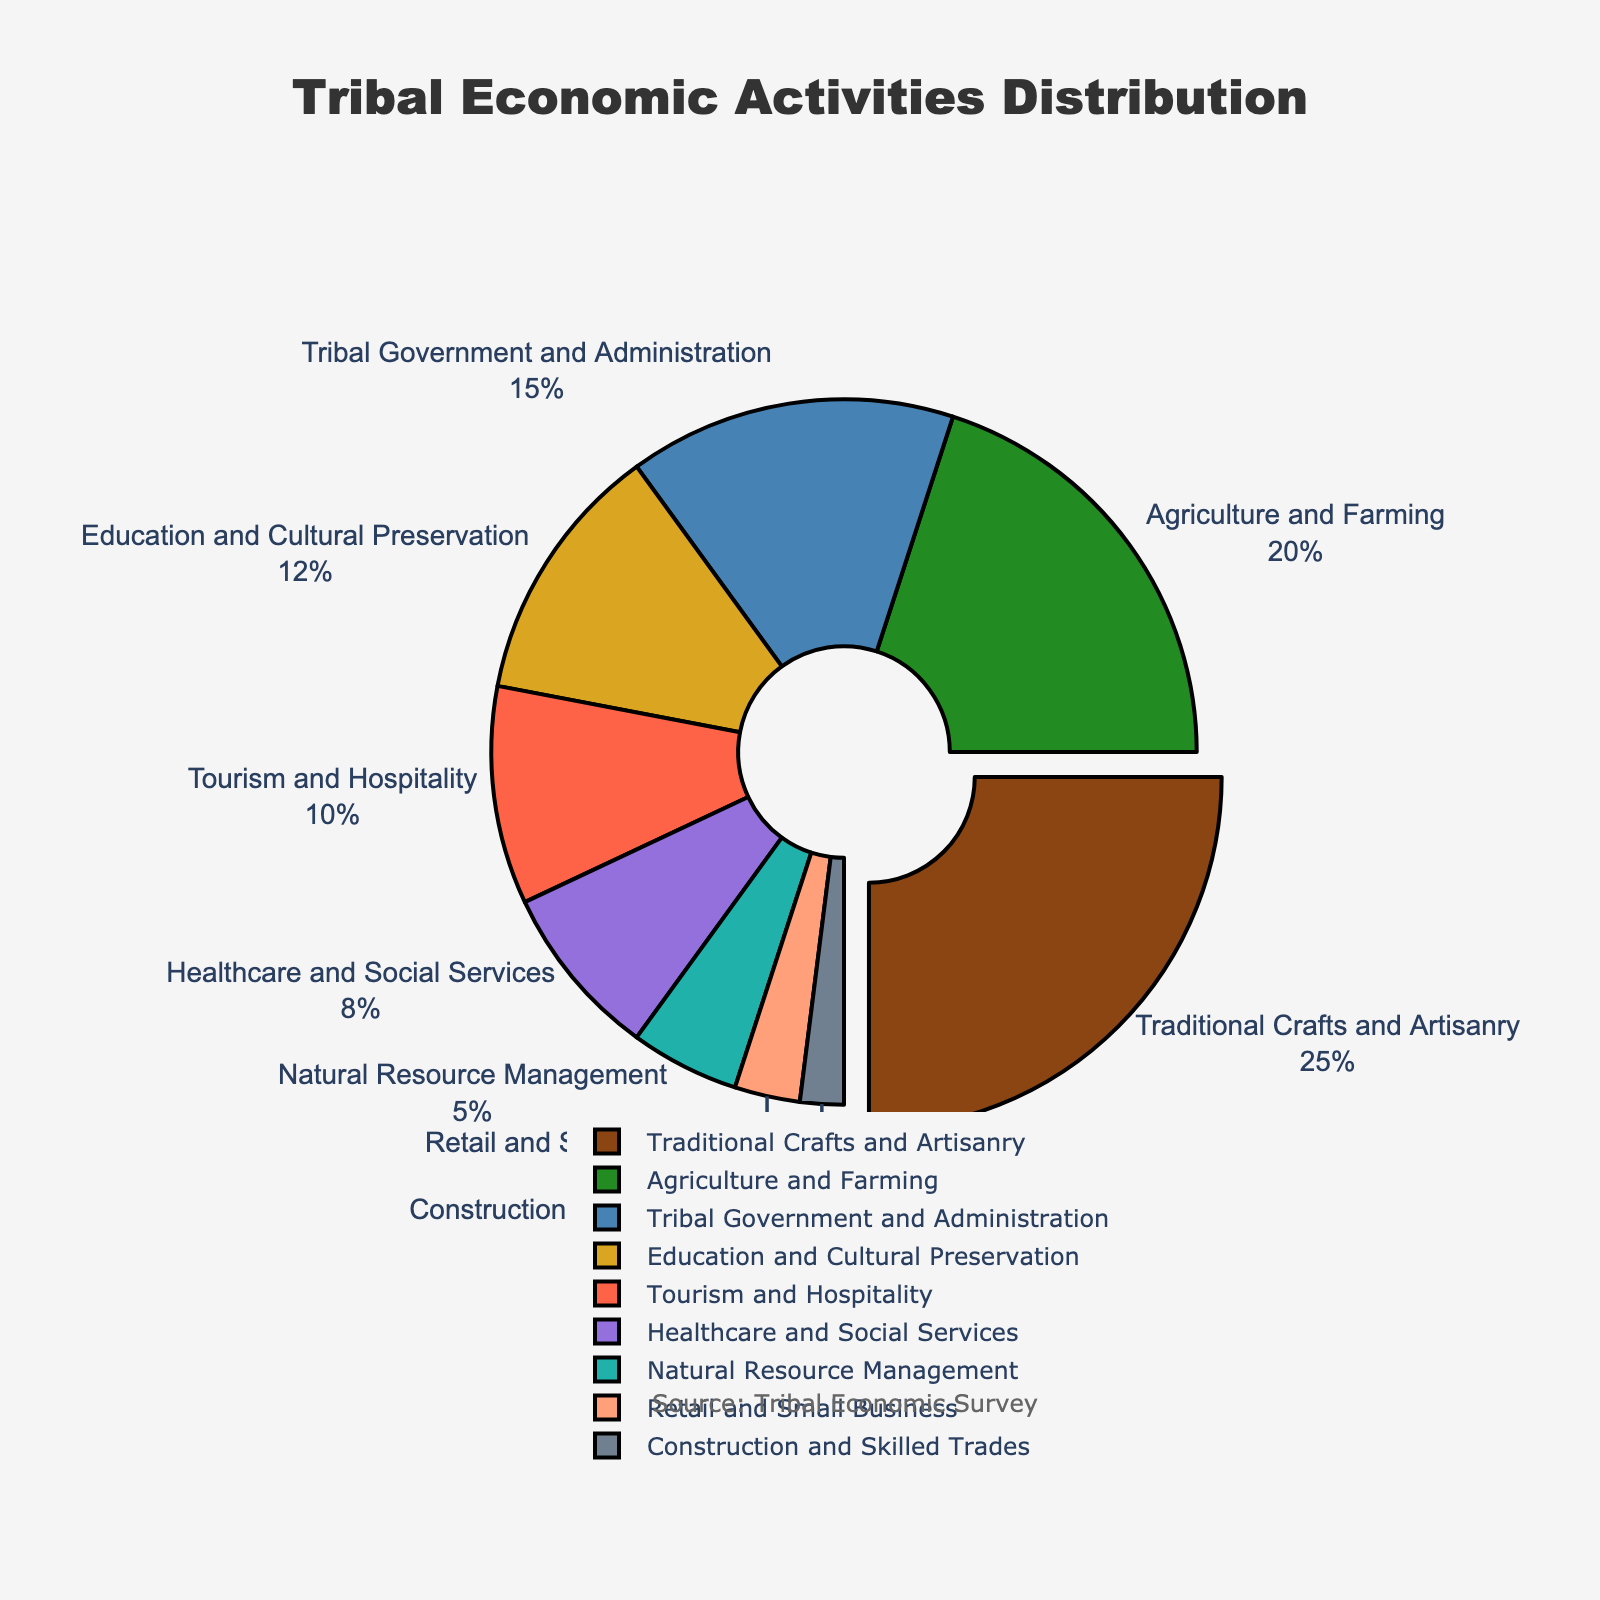What economic activity occupies the largest proportion of tribal members? The pie chart shows different economic activities engaged by tribal members with respective percentages. Traditional Crafts and Artisanry segment is slightly pulled away, signifying it as the largest segment with 25%.
Answer: Traditional Crafts and Artisanry Which economic activities combined make up at least half of the tribal members? To find the combined activities making up 50% or more, sum the segments starting from the largest until you reach or exceed 50%. Traditional Crafts and Artisanry (25%) plus Agriculture and Farming (20%) equals 45%. Adding Tribal Government and Administration (15%) brings the total to 60%.
Answer: Traditional Crafts and Artisanry, Agriculture and Farming, Tribal Government and Administration Compare the proportion of tribal members engaged in Agriculture and Farming to those in Education and Cultural Preservation. According to the chart, Agriculture and Farming has a proportion of 20%, while Education and Cultural Preservation has 12%. 20% is greater than 12%.
Answer: Agriculture and Farming has a higher proportion How do Tourism and Hospitality compare to Healthcare and Social Services in terms of proportions? Tourism and Hospitality accounts for 10% and Healthcare and Social Services for 8% of the tribal members' economic activities. 10% is greater than 8%.
Answer: Tourism and Hospitality has a higher proportion What is the sum of the proportions of Retail and Small Business and Construction and Skilled Trades? Retail and Small Business comprises 3% while Construction and Skilled Trades comprises 2%. Adding these values gives 3% + 2% = 5%.
Answer: 5% Which economic activity is represented by the green color in the pie chart? Observing the visual in the pie chart, the green color segment corresponds to Agriculture and Farming.
Answer: Agriculture and Farming Is the proportion of tribal members in Natural Resource Management greater than those in Retail and Small Business? From the pie chart, Natural Resource Management has a proportion of 5% and Retail and Small Business has 3%. 5% is greater than 3%.
Answer: Yes What is the combined proportion of Tourism and Hospitality and Natural Resource Management? Tourism and Hospitality accounts for 10% while Natural Resource Management comprises 5%. Adding these values gives 10% + 5% = 15%.
Answer: 15% What economic activity has the smallest proportion of tribal members? By examining the segments in the pie chart, Construction and Skilled Trades is the smallest with 2%.
Answer: Construction and Skilled Trades Compare the combined proportion of Healthcare and Social Services and Education and Cultural Preservation to Traditional Crafts and Artisanry. Healthcare and Social Services has 8% and Education and Cultural Preservation has 12%. Their combined proportion is 8% + 12% = 20%. Traditional Crafts and Artisanry alone makes up 25%. 20% is less than 25%.
Answer: Traditional Crafts and Artisanry has a higher proportion 